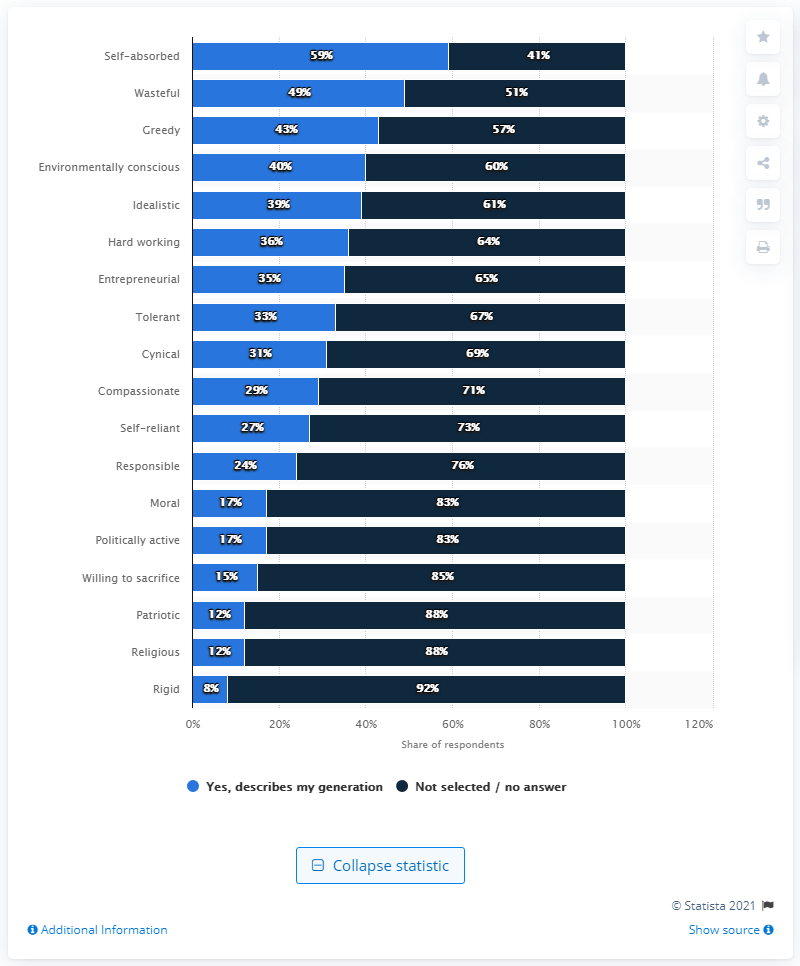Draw attention to some important aspects in this diagram. Forty-three percent of the people surveyed agreed that the word "greedy" describes their generation. The difference between "yes" and "no" is greatest when comparing the two words before "rigid. 